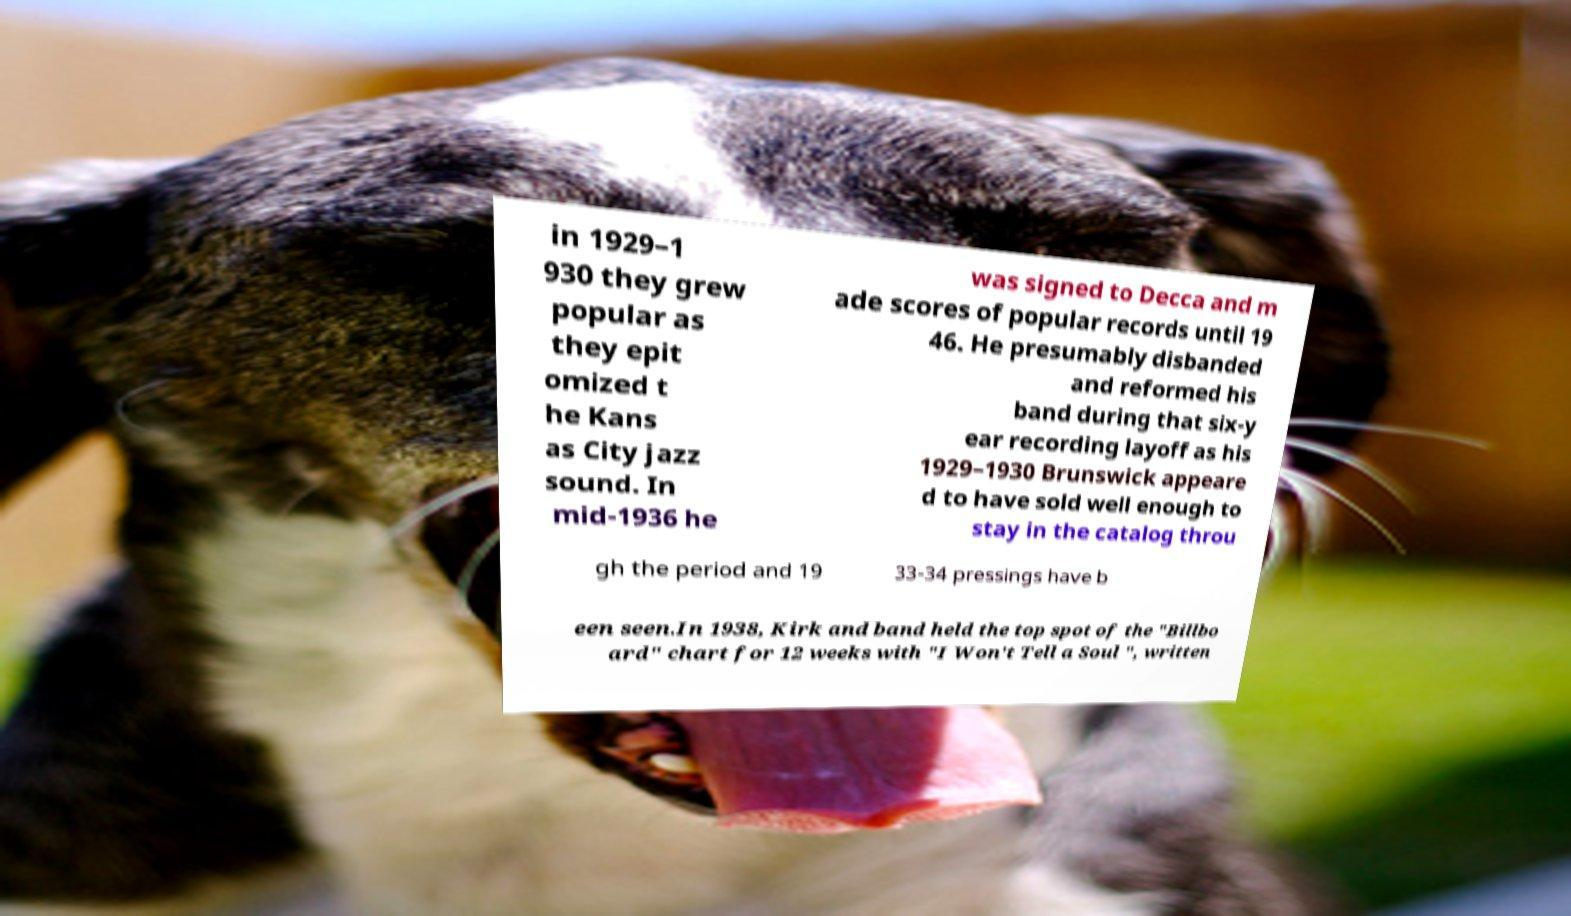Could you assist in decoding the text presented in this image and type it out clearly? in 1929–1 930 they grew popular as they epit omized t he Kans as City jazz sound. In mid-1936 he was signed to Decca and m ade scores of popular records until 19 46. He presumably disbanded and reformed his band during that six-y ear recording layoff as his 1929–1930 Brunswick appeare d to have sold well enough to stay in the catalog throu gh the period and 19 33-34 pressings have b een seen.In 1938, Kirk and band held the top spot of the "Billbo ard" chart for 12 weeks with "I Won't Tell a Soul ", written 